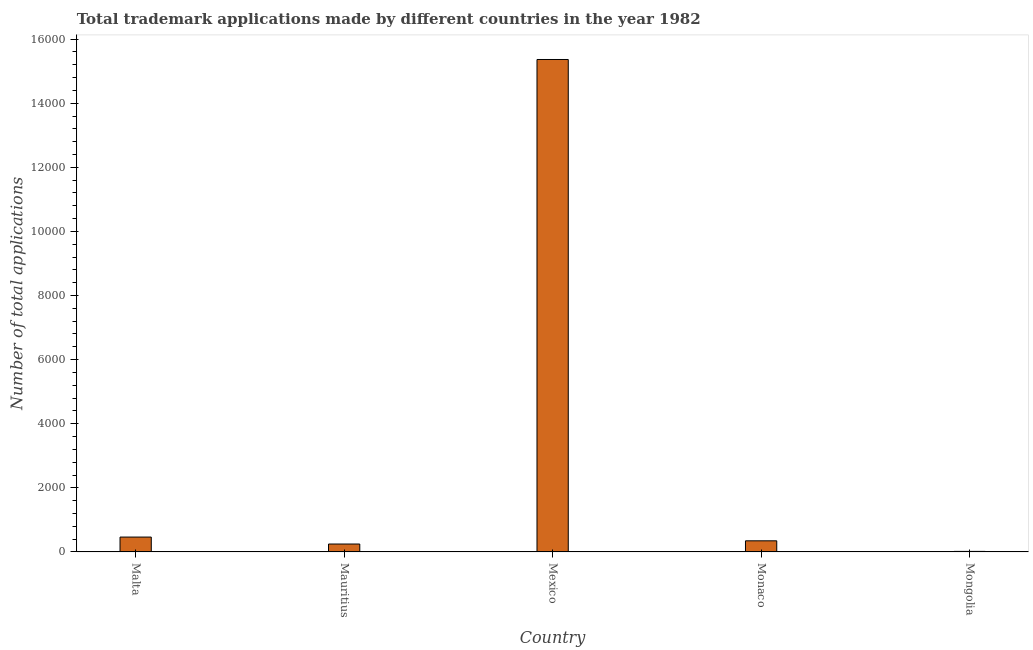What is the title of the graph?
Offer a terse response. Total trademark applications made by different countries in the year 1982. What is the label or title of the X-axis?
Your answer should be very brief. Country. What is the label or title of the Y-axis?
Your answer should be compact. Number of total applications. What is the number of trademark applications in Monaco?
Give a very brief answer. 347. Across all countries, what is the maximum number of trademark applications?
Ensure brevity in your answer.  1.54e+04. In which country was the number of trademark applications maximum?
Give a very brief answer. Mexico. In which country was the number of trademark applications minimum?
Provide a succinct answer. Mongolia. What is the sum of the number of trademark applications?
Your answer should be compact. 1.64e+04. What is the difference between the number of trademark applications in Mauritius and Mexico?
Ensure brevity in your answer.  -1.51e+04. What is the average number of trademark applications per country?
Your answer should be compact. 3287. What is the median number of trademark applications?
Provide a succinct answer. 347. What is the ratio of the number of trademark applications in Mauritius to that in Mexico?
Keep it short and to the point. 0.02. Is the number of trademark applications in Mauritius less than that in Mexico?
Ensure brevity in your answer.  Yes. What is the difference between the highest and the second highest number of trademark applications?
Provide a short and direct response. 1.49e+04. What is the difference between the highest and the lowest number of trademark applications?
Ensure brevity in your answer.  1.53e+04. How many bars are there?
Keep it short and to the point. 5. Are all the bars in the graph horizontal?
Give a very brief answer. No. How many countries are there in the graph?
Keep it short and to the point. 5. What is the difference between two consecutive major ticks on the Y-axis?
Offer a very short reply. 2000. Are the values on the major ticks of Y-axis written in scientific E-notation?
Your answer should be very brief. No. What is the Number of total applications of Malta?
Offer a terse response. 464. What is the Number of total applications in Mauritius?
Offer a very short reply. 247. What is the Number of total applications of Mexico?
Provide a short and direct response. 1.54e+04. What is the Number of total applications in Monaco?
Provide a succinct answer. 347. What is the difference between the Number of total applications in Malta and Mauritius?
Keep it short and to the point. 217. What is the difference between the Number of total applications in Malta and Mexico?
Your answer should be very brief. -1.49e+04. What is the difference between the Number of total applications in Malta and Monaco?
Your answer should be compact. 117. What is the difference between the Number of total applications in Malta and Mongolia?
Offer a very short reply. 447. What is the difference between the Number of total applications in Mauritius and Mexico?
Your response must be concise. -1.51e+04. What is the difference between the Number of total applications in Mauritius and Monaco?
Offer a very short reply. -100. What is the difference between the Number of total applications in Mauritius and Mongolia?
Your response must be concise. 230. What is the difference between the Number of total applications in Mexico and Monaco?
Your answer should be very brief. 1.50e+04. What is the difference between the Number of total applications in Mexico and Mongolia?
Offer a terse response. 1.53e+04. What is the difference between the Number of total applications in Monaco and Mongolia?
Provide a succinct answer. 330. What is the ratio of the Number of total applications in Malta to that in Mauritius?
Your response must be concise. 1.88. What is the ratio of the Number of total applications in Malta to that in Monaco?
Offer a very short reply. 1.34. What is the ratio of the Number of total applications in Malta to that in Mongolia?
Offer a very short reply. 27.29. What is the ratio of the Number of total applications in Mauritius to that in Mexico?
Offer a very short reply. 0.02. What is the ratio of the Number of total applications in Mauritius to that in Monaco?
Ensure brevity in your answer.  0.71. What is the ratio of the Number of total applications in Mauritius to that in Mongolia?
Keep it short and to the point. 14.53. What is the ratio of the Number of total applications in Mexico to that in Monaco?
Your answer should be compact. 44.28. What is the ratio of the Number of total applications in Mexico to that in Mongolia?
Your response must be concise. 903.76. What is the ratio of the Number of total applications in Monaco to that in Mongolia?
Keep it short and to the point. 20.41. 